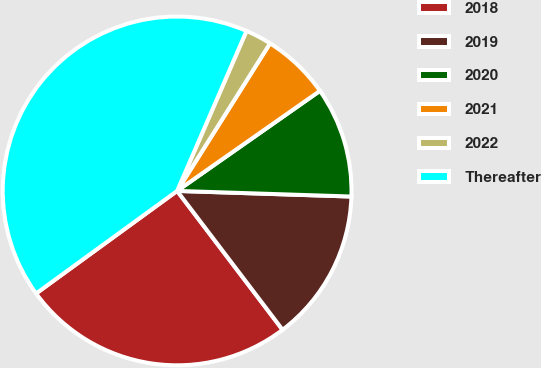Convert chart. <chart><loc_0><loc_0><loc_500><loc_500><pie_chart><fcel>2018<fcel>2019<fcel>2020<fcel>2021<fcel>2022<fcel>Thereafter<nl><fcel>25.33%<fcel>14.15%<fcel>10.24%<fcel>6.33%<fcel>2.43%<fcel>41.52%<nl></chart> 